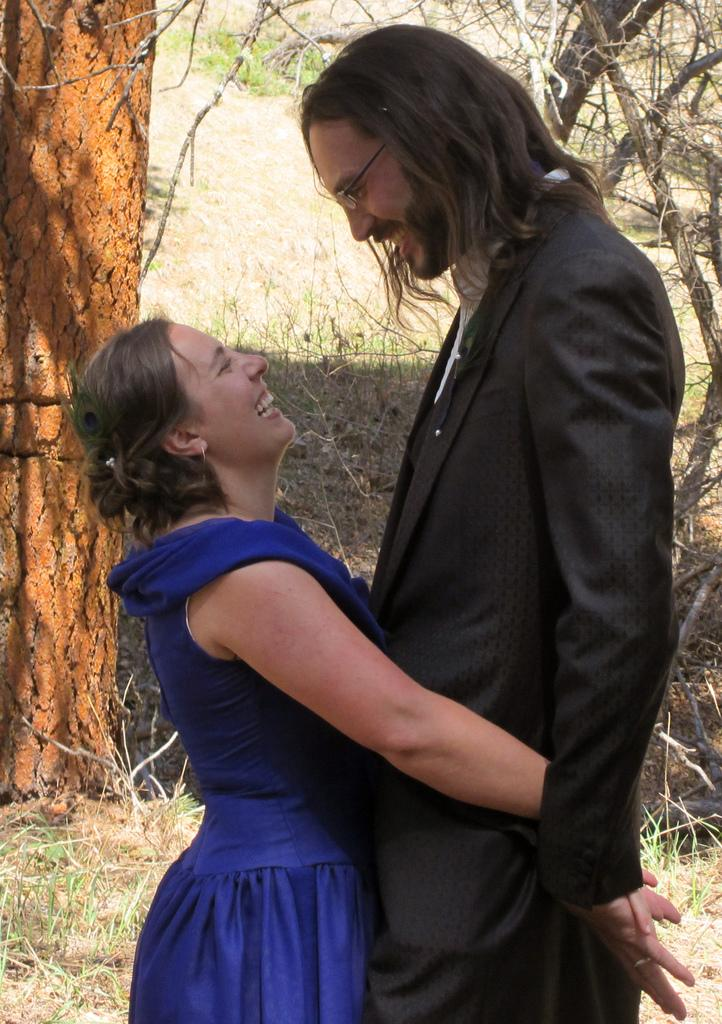What is happening in the image involving the people? In the image, a woman is holding a man with her hands. What can be seen in the background of the image? There are trees visible in the background of the image. What type of terrain is present in the image? Grass is present on the ground in the image. What type of juice is being served in the lunchroom in the image? There is no lunchroom or juice present in the image. 